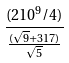Convert formula to latex. <formula><loc_0><loc_0><loc_500><loc_500>\frac { ( 2 1 0 ^ { 9 } / 4 ) } { \frac { ( \sqrt { 9 } + 3 1 7 ) } { \sqrt { 5 } } }</formula> 